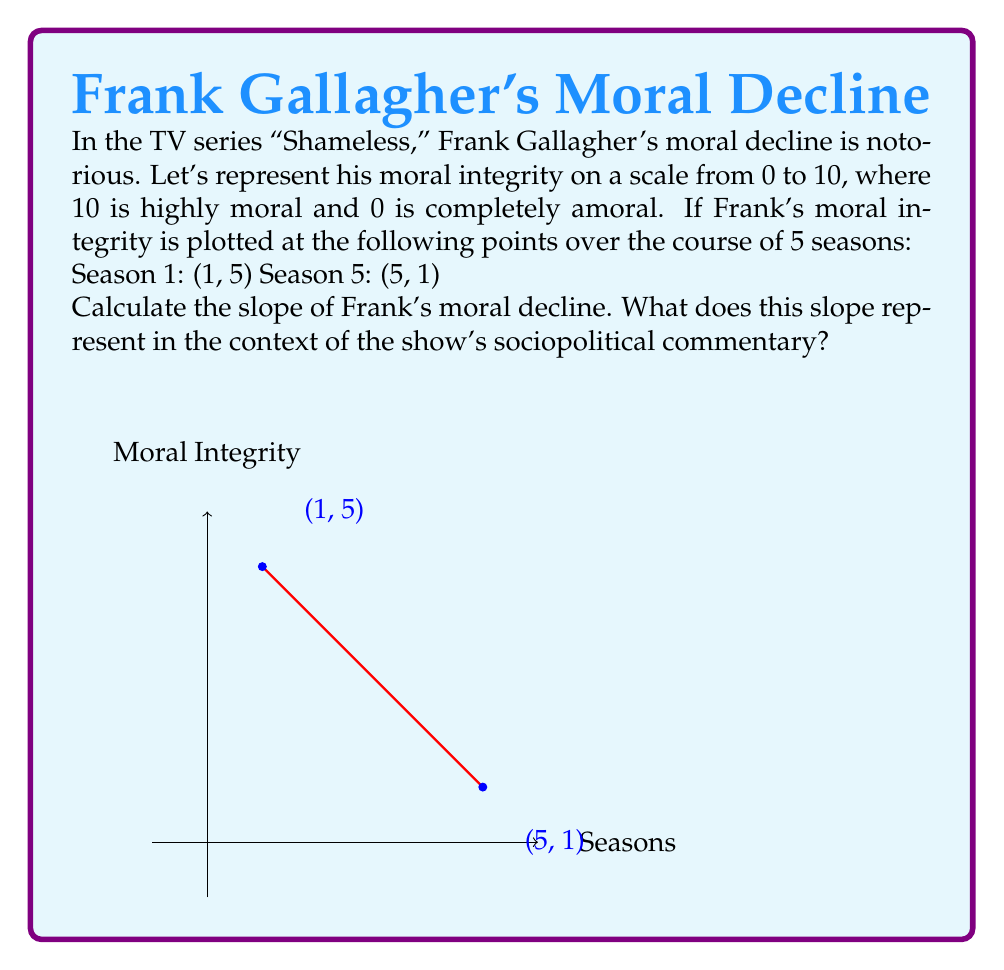Could you help me with this problem? To calculate the slope of Frank's moral decline, we'll use the slope formula:

$$ m = \frac{y_2 - y_1}{x_2 - x_1} $$

Where $(x_1, y_1)$ is the first point and $(x_2, y_2)$ is the second point.

Given:
$(x_1, y_1) = (1, 5)$ (Season 1)
$(x_2, y_2) = (5, 1)$ (Season 5)

Let's plug these values into the formula:

$$ m = \frac{1 - 5}{5 - 1} = \frac{-4}{4} = -1 $$

The slope is -1, which represents the rate of Frank's moral decline per season.

In the context of the show's sociopolitical commentary, this negative slope indicates:

1. A consistent downward trajectory in Frank's moral integrity over time.
2. The rate of decline is one unit of moral integrity per season, suggesting a steady erosion of values.
3. It reflects the show's critique of how systemic issues and personal choices can lead to a gradual but significant moral deterioration.
4. The linear nature of the decline might symbolize the predictability and inevitability of Frank's behavior, despite changing circumstances.

This mathematical representation aligns with the show's raw portrayal of how socioeconomic pressures and personal flaws can contribute to a character's moral decay, serving as a microcosm for broader societal issues.
Answer: $-1$ 